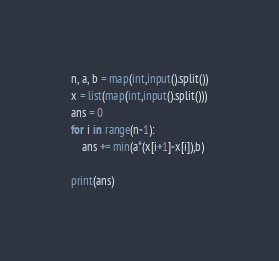Convert code to text. <code><loc_0><loc_0><loc_500><loc_500><_Python_>n, a, b = map(int,input().split())
x = list(map(int,input().split()))
ans = 0
for i in range(n-1):
    ans += min(a*(x[i+1]-x[i]),b)

print(ans)

</code> 